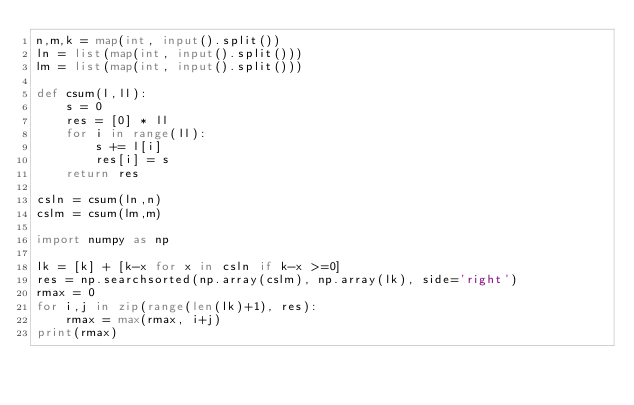<code> <loc_0><loc_0><loc_500><loc_500><_Python_>n,m,k = map(int, input().split())
ln = list(map(int, input().split()))
lm = list(map(int, input().split()))

def csum(l,ll):
    s = 0
    res = [0] * ll
    for i in range(ll):
        s += l[i]
        res[i] = s
    return res

csln = csum(ln,n)
cslm = csum(lm,m)

import numpy as np

lk = [k] + [k-x for x in csln if k-x >=0]
res = np.searchsorted(np.array(cslm), np.array(lk), side='right')
rmax = 0
for i,j in zip(range(len(lk)+1), res):
    rmax = max(rmax, i+j)
print(rmax)</code> 